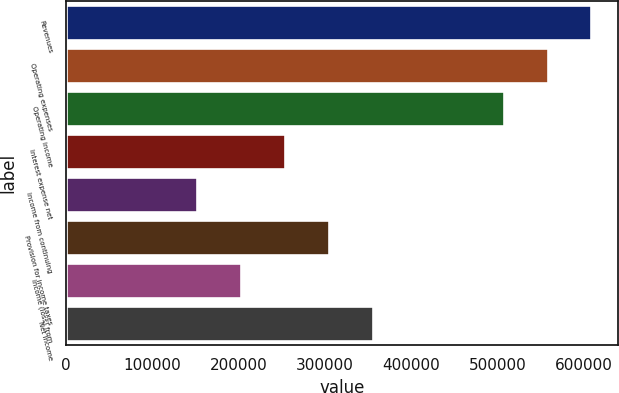Convert chart. <chart><loc_0><loc_0><loc_500><loc_500><bar_chart><fcel>Revenues<fcel>Operating expenses<fcel>Operating income<fcel>Interest expense net<fcel>Income from continuing<fcel>Provision for income taxes<fcel>Income (loss) from<fcel>Net income<nl><fcel>609098<fcel>558340<fcel>507582<fcel>253791<fcel>152275<fcel>304550<fcel>203033<fcel>355308<nl></chart> 